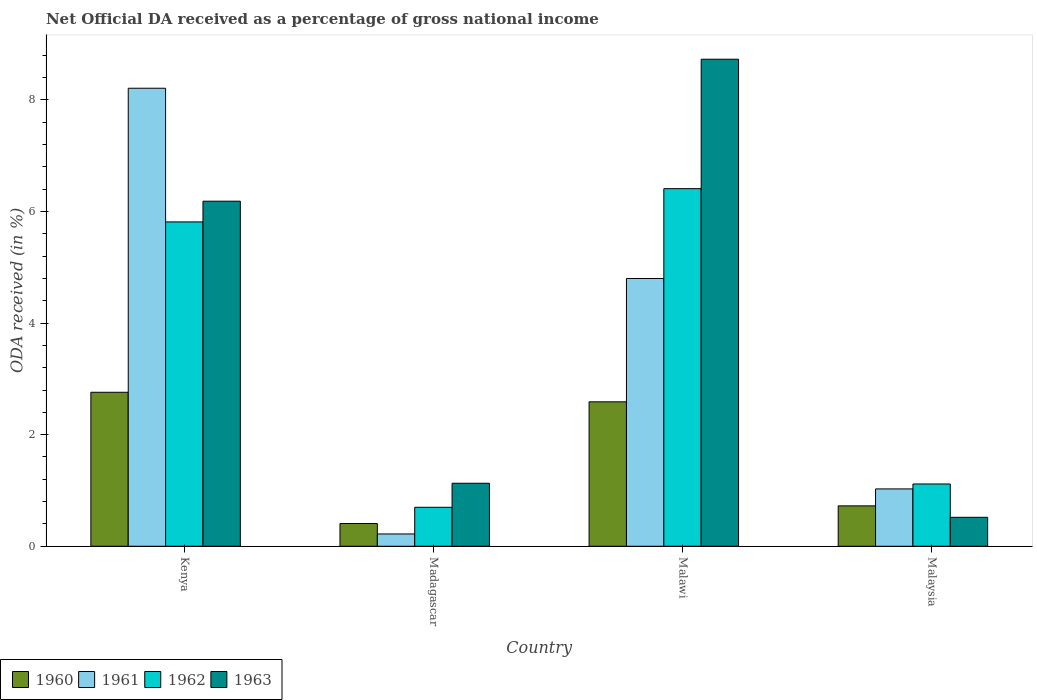How many different coloured bars are there?
Your answer should be very brief. 4. How many groups of bars are there?
Offer a terse response. 4. How many bars are there on the 1st tick from the left?
Ensure brevity in your answer.  4. How many bars are there on the 4th tick from the right?
Offer a very short reply. 4. What is the label of the 4th group of bars from the left?
Your answer should be very brief. Malaysia. What is the net official DA received in 1963 in Malaysia?
Your response must be concise. 0.52. Across all countries, what is the maximum net official DA received in 1963?
Offer a very short reply. 8.73. Across all countries, what is the minimum net official DA received in 1961?
Ensure brevity in your answer.  0.22. In which country was the net official DA received in 1961 maximum?
Give a very brief answer. Kenya. In which country was the net official DA received in 1961 minimum?
Provide a succinct answer. Madagascar. What is the total net official DA received in 1962 in the graph?
Provide a succinct answer. 14.04. What is the difference between the net official DA received in 1960 in Madagascar and that in Malaysia?
Offer a terse response. -0.32. What is the difference between the net official DA received in 1961 in Malawi and the net official DA received in 1963 in Madagascar?
Your answer should be very brief. 3.67. What is the average net official DA received in 1961 per country?
Ensure brevity in your answer.  3.56. What is the difference between the net official DA received of/in 1962 and net official DA received of/in 1963 in Malawi?
Offer a very short reply. -2.32. What is the ratio of the net official DA received in 1961 in Malawi to that in Malaysia?
Your response must be concise. 4.67. Is the net official DA received in 1961 in Malawi less than that in Malaysia?
Make the answer very short. No. What is the difference between the highest and the second highest net official DA received in 1961?
Make the answer very short. 7.18. What is the difference between the highest and the lowest net official DA received in 1961?
Keep it short and to the point. 7.99. In how many countries, is the net official DA received in 1962 greater than the average net official DA received in 1962 taken over all countries?
Offer a very short reply. 2. Is the sum of the net official DA received in 1963 in Kenya and Malawi greater than the maximum net official DA received in 1960 across all countries?
Give a very brief answer. Yes. What does the 1st bar from the right in Madagascar represents?
Your response must be concise. 1963. Are all the bars in the graph horizontal?
Your answer should be very brief. No. How many countries are there in the graph?
Keep it short and to the point. 4. Does the graph contain any zero values?
Offer a terse response. No. Does the graph contain grids?
Your answer should be compact. No. Where does the legend appear in the graph?
Provide a short and direct response. Bottom left. How many legend labels are there?
Provide a short and direct response. 4. How are the legend labels stacked?
Make the answer very short. Horizontal. What is the title of the graph?
Your answer should be very brief. Net Official DA received as a percentage of gross national income. What is the label or title of the X-axis?
Your answer should be very brief. Country. What is the label or title of the Y-axis?
Offer a terse response. ODA received (in %). What is the ODA received (in %) in 1960 in Kenya?
Provide a succinct answer. 2.76. What is the ODA received (in %) of 1961 in Kenya?
Provide a succinct answer. 8.21. What is the ODA received (in %) of 1962 in Kenya?
Offer a very short reply. 5.81. What is the ODA received (in %) in 1963 in Kenya?
Offer a terse response. 6.18. What is the ODA received (in %) in 1960 in Madagascar?
Offer a very short reply. 0.41. What is the ODA received (in %) of 1961 in Madagascar?
Your response must be concise. 0.22. What is the ODA received (in %) in 1962 in Madagascar?
Provide a succinct answer. 0.7. What is the ODA received (in %) of 1963 in Madagascar?
Offer a terse response. 1.13. What is the ODA received (in %) of 1960 in Malawi?
Provide a short and direct response. 2.59. What is the ODA received (in %) of 1961 in Malawi?
Offer a terse response. 4.8. What is the ODA received (in %) of 1962 in Malawi?
Provide a succinct answer. 6.41. What is the ODA received (in %) of 1963 in Malawi?
Provide a short and direct response. 8.73. What is the ODA received (in %) of 1960 in Malaysia?
Your response must be concise. 0.72. What is the ODA received (in %) of 1961 in Malaysia?
Offer a terse response. 1.03. What is the ODA received (in %) of 1962 in Malaysia?
Give a very brief answer. 1.12. What is the ODA received (in %) in 1963 in Malaysia?
Offer a terse response. 0.52. Across all countries, what is the maximum ODA received (in %) in 1960?
Keep it short and to the point. 2.76. Across all countries, what is the maximum ODA received (in %) of 1961?
Provide a short and direct response. 8.21. Across all countries, what is the maximum ODA received (in %) of 1962?
Your response must be concise. 6.41. Across all countries, what is the maximum ODA received (in %) of 1963?
Offer a terse response. 8.73. Across all countries, what is the minimum ODA received (in %) of 1960?
Your answer should be very brief. 0.41. Across all countries, what is the minimum ODA received (in %) in 1961?
Ensure brevity in your answer.  0.22. Across all countries, what is the minimum ODA received (in %) of 1962?
Give a very brief answer. 0.7. Across all countries, what is the minimum ODA received (in %) in 1963?
Your answer should be very brief. 0.52. What is the total ODA received (in %) of 1960 in the graph?
Ensure brevity in your answer.  6.48. What is the total ODA received (in %) of 1961 in the graph?
Give a very brief answer. 14.26. What is the total ODA received (in %) in 1962 in the graph?
Offer a terse response. 14.04. What is the total ODA received (in %) in 1963 in the graph?
Offer a terse response. 16.56. What is the difference between the ODA received (in %) in 1960 in Kenya and that in Madagascar?
Keep it short and to the point. 2.35. What is the difference between the ODA received (in %) of 1961 in Kenya and that in Madagascar?
Your answer should be very brief. 7.99. What is the difference between the ODA received (in %) of 1962 in Kenya and that in Madagascar?
Provide a succinct answer. 5.11. What is the difference between the ODA received (in %) of 1963 in Kenya and that in Madagascar?
Give a very brief answer. 5.06. What is the difference between the ODA received (in %) of 1960 in Kenya and that in Malawi?
Ensure brevity in your answer.  0.17. What is the difference between the ODA received (in %) in 1961 in Kenya and that in Malawi?
Offer a terse response. 3.41. What is the difference between the ODA received (in %) in 1962 in Kenya and that in Malawi?
Your response must be concise. -0.6. What is the difference between the ODA received (in %) in 1963 in Kenya and that in Malawi?
Your answer should be very brief. -2.54. What is the difference between the ODA received (in %) of 1960 in Kenya and that in Malaysia?
Your response must be concise. 2.04. What is the difference between the ODA received (in %) in 1961 in Kenya and that in Malaysia?
Provide a short and direct response. 7.18. What is the difference between the ODA received (in %) of 1962 in Kenya and that in Malaysia?
Your answer should be very brief. 4.7. What is the difference between the ODA received (in %) in 1963 in Kenya and that in Malaysia?
Ensure brevity in your answer.  5.67. What is the difference between the ODA received (in %) in 1960 in Madagascar and that in Malawi?
Provide a succinct answer. -2.18. What is the difference between the ODA received (in %) in 1961 in Madagascar and that in Malawi?
Give a very brief answer. -4.58. What is the difference between the ODA received (in %) of 1962 in Madagascar and that in Malawi?
Your response must be concise. -5.71. What is the difference between the ODA received (in %) in 1963 in Madagascar and that in Malawi?
Ensure brevity in your answer.  -7.6. What is the difference between the ODA received (in %) in 1960 in Madagascar and that in Malaysia?
Your answer should be compact. -0.32. What is the difference between the ODA received (in %) of 1961 in Madagascar and that in Malaysia?
Your answer should be very brief. -0.81. What is the difference between the ODA received (in %) in 1962 in Madagascar and that in Malaysia?
Give a very brief answer. -0.42. What is the difference between the ODA received (in %) in 1963 in Madagascar and that in Malaysia?
Keep it short and to the point. 0.61. What is the difference between the ODA received (in %) in 1960 in Malawi and that in Malaysia?
Provide a succinct answer. 1.86. What is the difference between the ODA received (in %) in 1961 in Malawi and that in Malaysia?
Offer a very short reply. 3.77. What is the difference between the ODA received (in %) of 1962 in Malawi and that in Malaysia?
Offer a very short reply. 5.29. What is the difference between the ODA received (in %) in 1963 in Malawi and that in Malaysia?
Your response must be concise. 8.21. What is the difference between the ODA received (in %) of 1960 in Kenya and the ODA received (in %) of 1961 in Madagascar?
Provide a short and direct response. 2.54. What is the difference between the ODA received (in %) in 1960 in Kenya and the ODA received (in %) in 1962 in Madagascar?
Offer a very short reply. 2.06. What is the difference between the ODA received (in %) in 1960 in Kenya and the ODA received (in %) in 1963 in Madagascar?
Give a very brief answer. 1.63. What is the difference between the ODA received (in %) of 1961 in Kenya and the ODA received (in %) of 1962 in Madagascar?
Provide a succinct answer. 7.51. What is the difference between the ODA received (in %) in 1961 in Kenya and the ODA received (in %) in 1963 in Madagascar?
Provide a succinct answer. 7.08. What is the difference between the ODA received (in %) of 1962 in Kenya and the ODA received (in %) of 1963 in Madagascar?
Your answer should be very brief. 4.68. What is the difference between the ODA received (in %) in 1960 in Kenya and the ODA received (in %) in 1961 in Malawi?
Provide a short and direct response. -2.04. What is the difference between the ODA received (in %) of 1960 in Kenya and the ODA received (in %) of 1962 in Malawi?
Ensure brevity in your answer.  -3.65. What is the difference between the ODA received (in %) of 1960 in Kenya and the ODA received (in %) of 1963 in Malawi?
Your answer should be compact. -5.97. What is the difference between the ODA received (in %) in 1961 in Kenya and the ODA received (in %) in 1962 in Malawi?
Keep it short and to the point. 1.8. What is the difference between the ODA received (in %) of 1961 in Kenya and the ODA received (in %) of 1963 in Malawi?
Offer a terse response. -0.52. What is the difference between the ODA received (in %) of 1962 in Kenya and the ODA received (in %) of 1963 in Malawi?
Keep it short and to the point. -2.92. What is the difference between the ODA received (in %) in 1960 in Kenya and the ODA received (in %) in 1961 in Malaysia?
Offer a very short reply. 1.73. What is the difference between the ODA received (in %) of 1960 in Kenya and the ODA received (in %) of 1962 in Malaysia?
Provide a succinct answer. 1.64. What is the difference between the ODA received (in %) in 1960 in Kenya and the ODA received (in %) in 1963 in Malaysia?
Provide a succinct answer. 2.24. What is the difference between the ODA received (in %) of 1961 in Kenya and the ODA received (in %) of 1962 in Malaysia?
Your answer should be compact. 7.09. What is the difference between the ODA received (in %) of 1961 in Kenya and the ODA received (in %) of 1963 in Malaysia?
Offer a very short reply. 7.69. What is the difference between the ODA received (in %) in 1962 in Kenya and the ODA received (in %) in 1963 in Malaysia?
Your response must be concise. 5.29. What is the difference between the ODA received (in %) in 1960 in Madagascar and the ODA received (in %) in 1961 in Malawi?
Offer a very short reply. -4.39. What is the difference between the ODA received (in %) of 1960 in Madagascar and the ODA received (in %) of 1962 in Malawi?
Give a very brief answer. -6. What is the difference between the ODA received (in %) in 1960 in Madagascar and the ODA received (in %) in 1963 in Malawi?
Your answer should be compact. -8.32. What is the difference between the ODA received (in %) of 1961 in Madagascar and the ODA received (in %) of 1962 in Malawi?
Provide a short and direct response. -6.19. What is the difference between the ODA received (in %) in 1961 in Madagascar and the ODA received (in %) in 1963 in Malawi?
Keep it short and to the point. -8.51. What is the difference between the ODA received (in %) in 1962 in Madagascar and the ODA received (in %) in 1963 in Malawi?
Your response must be concise. -8.03. What is the difference between the ODA received (in %) in 1960 in Madagascar and the ODA received (in %) in 1961 in Malaysia?
Provide a short and direct response. -0.62. What is the difference between the ODA received (in %) of 1960 in Madagascar and the ODA received (in %) of 1962 in Malaysia?
Make the answer very short. -0.71. What is the difference between the ODA received (in %) in 1960 in Madagascar and the ODA received (in %) in 1963 in Malaysia?
Provide a succinct answer. -0.11. What is the difference between the ODA received (in %) in 1961 in Madagascar and the ODA received (in %) in 1962 in Malaysia?
Your answer should be very brief. -0.9. What is the difference between the ODA received (in %) of 1961 in Madagascar and the ODA received (in %) of 1963 in Malaysia?
Give a very brief answer. -0.3. What is the difference between the ODA received (in %) of 1962 in Madagascar and the ODA received (in %) of 1963 in Malaysia?
Offer a terse response. 0.18. What is the difference between the ODA received (in %) in 1960 in Malawi and the ODA received (in %) in 1961 in Malaysia?
Give a very brief answer. 1.56. What is the difference between the ODA received (in %) of 1960 in Malawi and the ODA received (in %) of 1962 in Malaysia?
Provide a short and direct response. 1.47. What is the difference between the ODA received (in %) of 1960 in Malawi and the ODA received (in %) of 1963 in Malaysia?
Make the answer very short. 2.07. What is the difference between the ODA received (in %) of 1961 in Malawi and the ODA received (in %) of 1962 in Malaysia?
Your answer should be compact. 3.68. What is the difference between the ODA received (in %) in 1961 in Malawi and the ODA received (in %) in 1963 in Malaysia?
Keep it short and to the point. 4.28. What is the difference between the ODA received (in %) in 1962 in Malawi and the ODA received (in %) in 1963 in Malaysia?
Offer a very short reply. 5.89. What is the average ODA received (in %) of 1960 per country?
Ensure brevity in your answer.  1.62. What is the average ODA received (in %) in 1961 per country?
Provide a succinct answer. 3.56. What is the average ODA received (in %) in 1962 per country?
Provide a succinct answer. 3.51. What is the average ODA received (in %) of 1963 per country?
Provide a succinct answer. 4.14. What is the difference between the ODA received (in %) of 1960 and ODA received (in %) of 1961 in Kenya?
Your answer should be very brief. -5.45. What is the difference between the ODA received (in %) of 1960 and ODA received (in %) of 1962 in Kenya?
Give a very brief answer. -3.05. What is the difference between the ODA received (in %) of 1960 and ODA received (in %) of 1963 in Kenya?
Your response must be concise. -3.42. What is the difference between the ODA received (in %) in 1961 and ODA received (in %) in 1962 in Kenya?
Your answer should be compact. 2.4. What is the difference between the ODA received (in %) of 1961 and ODA received (in %) of 1963 in Kenya?
Offer a very short reply. 2.02. What is the difference between the ODA received (in %) of 1962 and ODA received (in %) of 1963 in Kenya?
Ensure brevity in your answer.  -0.37. What is the difference between the ODA received (in %) of 1960 and ODA received (in %) of 1961 in Madagascar?
Make the answer very short. 0.19. What is the difference between the ODA received (in %) in 1960 and ODA received (in %) in 1962 in Madagascar?
Offer a terse response. -0.29. What is the difference between the ODA received (in %) of 1960 and ODA received (in %) of 1963 in Madagascar?
Offer a terse response. -0.72. What is the difference between the ODA received (in %) in 1961 and ODA received (in %) in 1962 in Madagascar?
Your response must be concise. -0.48. What is the difference between the ODA received (in %) of 1961 and ODA received (in %) of 1963 in Madagascar?
Keep it short and to the point. -0.91. What is the difference between the ODA received (in %) of 1962 and ODA received (in %) of 1963 in Madagascar?
Your answer should be compact. -0.43. What is the difference between the ODA received (in %) of 1960 and ODA received (in %) of 1961 in Malawi?
Provide a succinct answer. -2.21. What is the difference between the ODA received (in %) in 1960 and ODA received (in %) in 1962 in Malawi?
Make the answer very short. -3.82. What is the difference between the ODA received (in %) of 1960 and ODA received (in %) of 1963 in Malawi?
Ensure brevity in your answer.  -6.14. What is the difference between the ODA received (in %) in 1961 and ODA received (in %) in 1962 in Malawi?
Your answer should be very brief. -1.61. What is the difference between the ODA received (in %) of 1961 and ODA received (in %) of 1963 in Malawi?
Give a very brief answer. -3.93. What is the difference between the ODA received (in %) in 1962 and ODA received (in %) in 1963 in Malawi?
Make the answer very short. -2.32. What is the difference between the ODA received (in %) in 1960 and ODA received (in %) in 1961 in Malaysia?
Make the answer very short. -0.3. What is the difference between the ODA received (in %) of 1960 and ODA received (in %) of 1962 in Malaysia?
Your answer should be compact. -0.39. What is the difference between the ODA received (in %) of 1960 and ODA received (in %) of 1963 in Malaysia?
Make the answer very short. 0.21. What is the difference between the ODA received (in %) of 1961 and ODA received (in %) of 1962 in Malaysia?
Keep it short and to the point. -0.09. What is the difference between the ODA received (in %) in 1961 and ODA received (in %) in 1963 in Malaysia?
Your response must be concise. 0.51. What is the difference between the ODA received (in %) of 1962 and ODA received (in %) of 1963 in Malaysia?
Your answer should be very brief. 0.6. What is the ratio of the ODA received (in %) in 1960 in Kenya to that in Madagascar?
Offer a terse response. 6.78. What is the ratio of the ODA received (in %) in 1961 in Kenya to that in Madagascar?
Offer a very short reply. 37.24. What is the ratio of the ODA received (in %) in 1962 in Kenya to that in Madagascar?
Your response must be concise. 8.32. What is the ratio of the ODA received (in %) in 1963 in Kenya to that in Madagascar?
Provide a succinct answer. 5.48. What is the ratio of the ODA received (in %) in 1960 in Kenya to that in Malawi?
Give a very brief answer. 1.07. What is the ratio of the ODA received (in %) of 1961 in Kenya to that in Malawi?
Keep it short and to the point. 1.71. What is the ratio of the ODA received (in %) of 1962 in Kenya to that in Malawi?
Ensure brevity in your answer.  0.91. What is the ratio of the ODA received (in %) in 1963 in Kenya to that in Malawi?
Offer a very short reply. 0.71. What is the ratio of the ODA received (in %) of 1960 in Kenya to that in Malaysia?
Offer a very short reply. 3.81. What is the ratio of the ODA received (in %) of 1961 in Kenya to that in Malaysia?
Offer a very short reply. 7.99. What is the ratio of the ODA received (in %) in 1962 in Kenya to that in Malaysia?
Make the answer very short. 5.21. What is the ratio of the ODA received (in %) in 1963 in Kenya to that in Malaysia?
Your answer should be compact. 11.92. What is the ratio of the ODA received (in %) in 1960 in Madagascar to that in Malawi?
Make the answer very short. 0.16. What is the ratio of the ODA received (in %) of 1961 in Madagascar to that in Malawi?
Make the answer very short. 0.05. What is the ratio of the ODA received (in %) in 1962 in Madagascar to that in Malawi?
Offer a terse response. 0.11. What is the ratio of the ODA received (in %) of 1963 in Madagascar to that in Malawi?
Give a very brief answer. 0.13. What is the ratio of the ODA received (in %) in 1960 in Madagascar to that in Malaysia?
Provide a succinct answer. 0.56. What is the ratio of the ODA received (in %) in 1961 in Madagascar to that in Malaysia?
Give a very brief answer. 0.21. What is the ratio of the ODA received (in %) in 1962 in Madagascar to that in Malaysia?
Provide a succinct answer. 0.63. What is the ratio of the ODA received (in %) of 1963 in Madagascar to that in Malaysia?
Your answer should be very brief. 2.18. What is the ratio of the ODA received (in %) in 1960 in Malawi to that in Malaysia?
Your response must be concise. 3.58. What is the ratio of the ODA received (in %) of 1961 in Malawi to that in Malaysia?
Provide a succinct answer. 4.67. What is the ratio of the ODA received (in %) in 1962 in Malawi to that in Malaysia?
Provide a short and direct response. 5.74. What is the ratio of the ODA received (in %) in 1963 in Malawi to that in Malaysia?
Provide a short and direct response. 16.83. What is the difference between the highest and the second highest ODA received (in %) of 1960?
Give a very brief answer. 0.17. What is the difference between the highest and the second highest ODA received (in %) in 1961?
Your response must be concise. 3.41. What is the difference between the highest and the second highest ODA received (in %) of 1962?
Provide a short and direct response. 0.6. What is the difference between the highest and the second highest ODA received (in %) of 1963?
Ensure brevity in your answer.  2.54. What is the difference between the highest and the lowest ODA received (in %) in 1960?
Make the answer very short. 2.35. What is the difference between the highest and the lowest ODA received (in %) of 1961?
Offer a very short reply. 7.99. What is the difference between the highest and the lowest ODA received (in %) of 1962?
Offer a very short reply. 5.71. What is the difference between the highest and the lowest ODA received (in %) in 1963?
Keep it short and to the point. 8.21. 